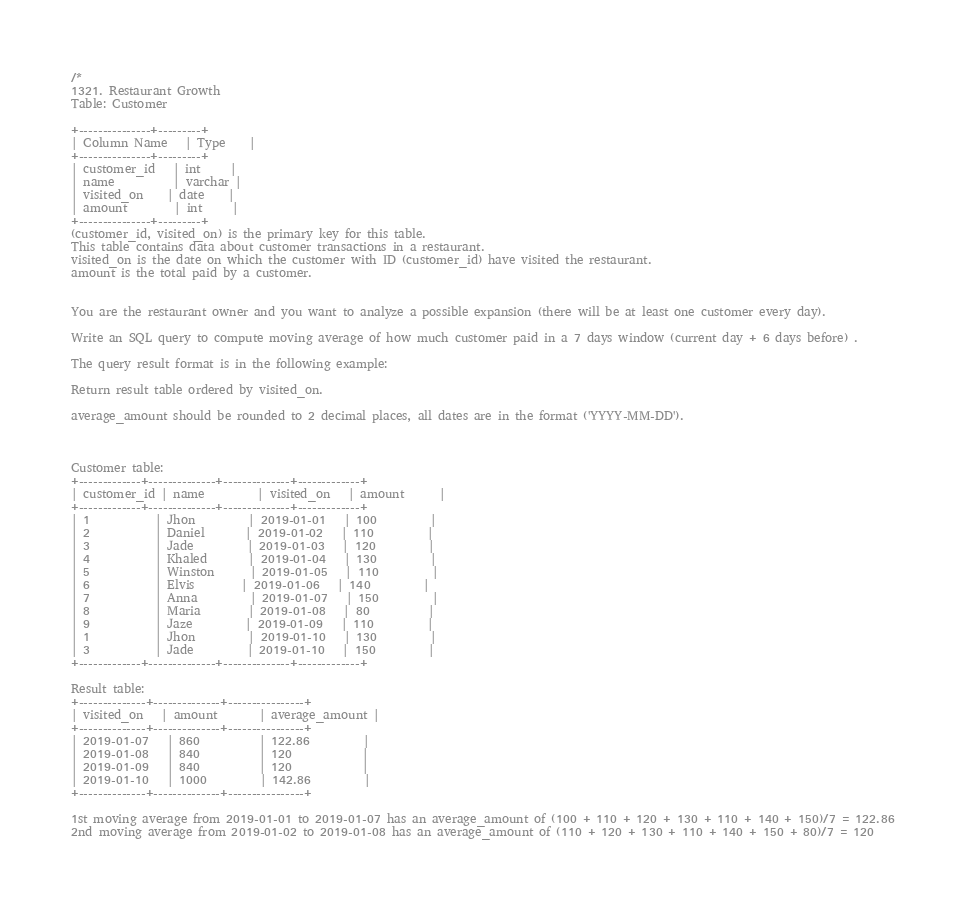<code> <loc_0><loc_0><loc_500><loc_500><_SQL_>/*
1321. Restaurant Growth
Table: Customer

+---------------+---------+
| Column Name   | Type    |
+---------------+---------+
| customer_id   | int     |
| name          | varchar |
| visited_on    | date    |
| amount        | int     |
+---------------+---------+
(customer_id, visited_on) is the primary key for this table.
This table contains data about customer transactions in a restaurant.
visited_on is the date on which the customer with ID (customer_id) have visited the restaurant.
amount is the total paid by a customer.
 

You are the restaurant owner and you want to analyze a possible expansion (there will be at least one customer every day).

Write an SQL query to compute moving average of how much customer paid in a 7 days window (current day + 6 days before) .

The query result format is in the following example:

Return result table ordered by visited_on.

average_amount should be rounded to 2 decimal places, all dates are in the format ('YYYY-MM-DD').

 

Customer table:
+-------------+--------------+--------------+-------------+
| customer_id | name         | visited_on   | amount      |
+-------------+--------------+--------------+-------------+
| 1           | Jhon         | 2019-01-01   | 100         |
| 2           | Daniel       | 2019-01-02   | 110         |
| 3           | Jade         | 2019-01-03   | 120         |
| 4           | Khaled       | 2019-01-04   | 130         |
| 5           | Winston      | 2019-01-05   | 110         | 
| 6           | Elvis        | 2019-01-06   | 140         | 
| 7           | Anna         | 2019-01-07   | 150         |
| 8           | Maria        | 2019-01-08   | 80          |
| 9           | Jaze         | 2019-01-09   | 110         | 
| 1           | Jhon         | 2019-01-10   | 130         | 
| 3           | Jade         | 2019-01-10   | 150         | 
+-------------+--------------+--------------+-------------+

Result table:
+--------------+--------------+----------------+
| visited_on   | amount       | average_amount |
+--------------+--------------+----------------+
| 2019-01-07   | 860          | 122.86         |
| 2019-01-08   | 840          | 120            |
| 2019-01-09   | 840          | 120            |
| 2019-01-10   | 1000         | 142.86         |
+--------------+--------------+----------------+

1st moving average from 2019-01-01 to 2019-01-07 has an average_amount of (100 + 110 + 120 + 130 + 110 + 140 + 150)/7 = 122.86
2nd moving average from 2019-01-02 to 2019-01-08 has an average_amount of (110 + 120 + 130 + 110 + 140 + 150 + 80)/7 = 120</code> 